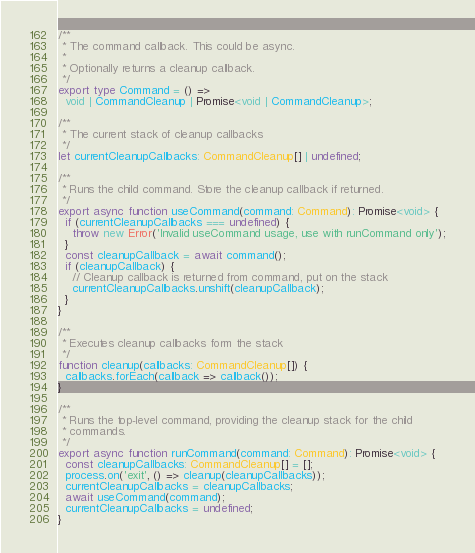<code> <loc_0><loc_0><loc_500><loc_500><_TypeScript_>/**
 * The command callback. This could be async.
 *
 * Optionally returns a cleanup callback.
 */
export type Command = () =>
  void | CommandCleanup | Promise<void | CommandCleanup>;

/**
 * The current stack of cleanup callbacks
 */
let currentCleanupCallbacks: CommandCleanup[] | undefined;

/**
 * Runs the child command. Store the cleanup callback if returned.
 */
export async function useCommand(command: Command): Promise<void> {
  if (currentCleanupCallbacks === undefined) {
    throw new Error('Invalid useCommand usage, use with runCommand only');
  }
  const cleanupCallback = await command();
  if (cleanupCallback) {
    // Cleanup callback is returned from command, put on the stack
    currentCleanupCallbacks.unshift(cleanupCallback);
  }
}

/**
 * Executes cleanup callbacks form the stack
 */
function cleanup(callbacks: CommandCleanup[]) {
  callbacks.forEach(callback => callback());
}

/**
 * Runs the top-level command, providing the cleanup stack for the child
 * commands.
 */
export async function runCommand(command: Command): Promise<void> {
  const cleanupCallbacks: CommandCleanup[] = [];
  process.on('exit', () => cleanup(cleanupCallbacks));
  currentCleanupCallbacks = cleanupCallbacks;
  await useCommand(command);
  currentCleanupCallbacks = undefined;
}
</code> 